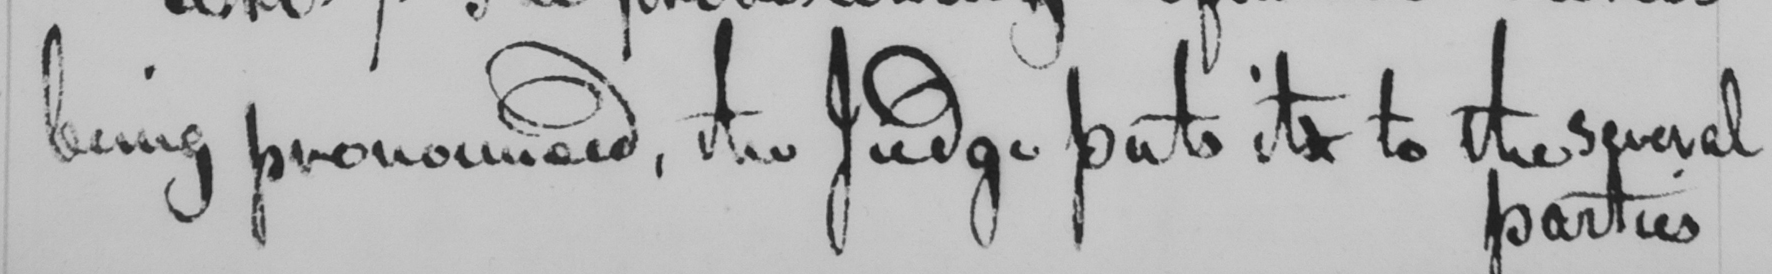Please transcribe the handwritten text in this image. being pronounced , the Judge puts its to the several 